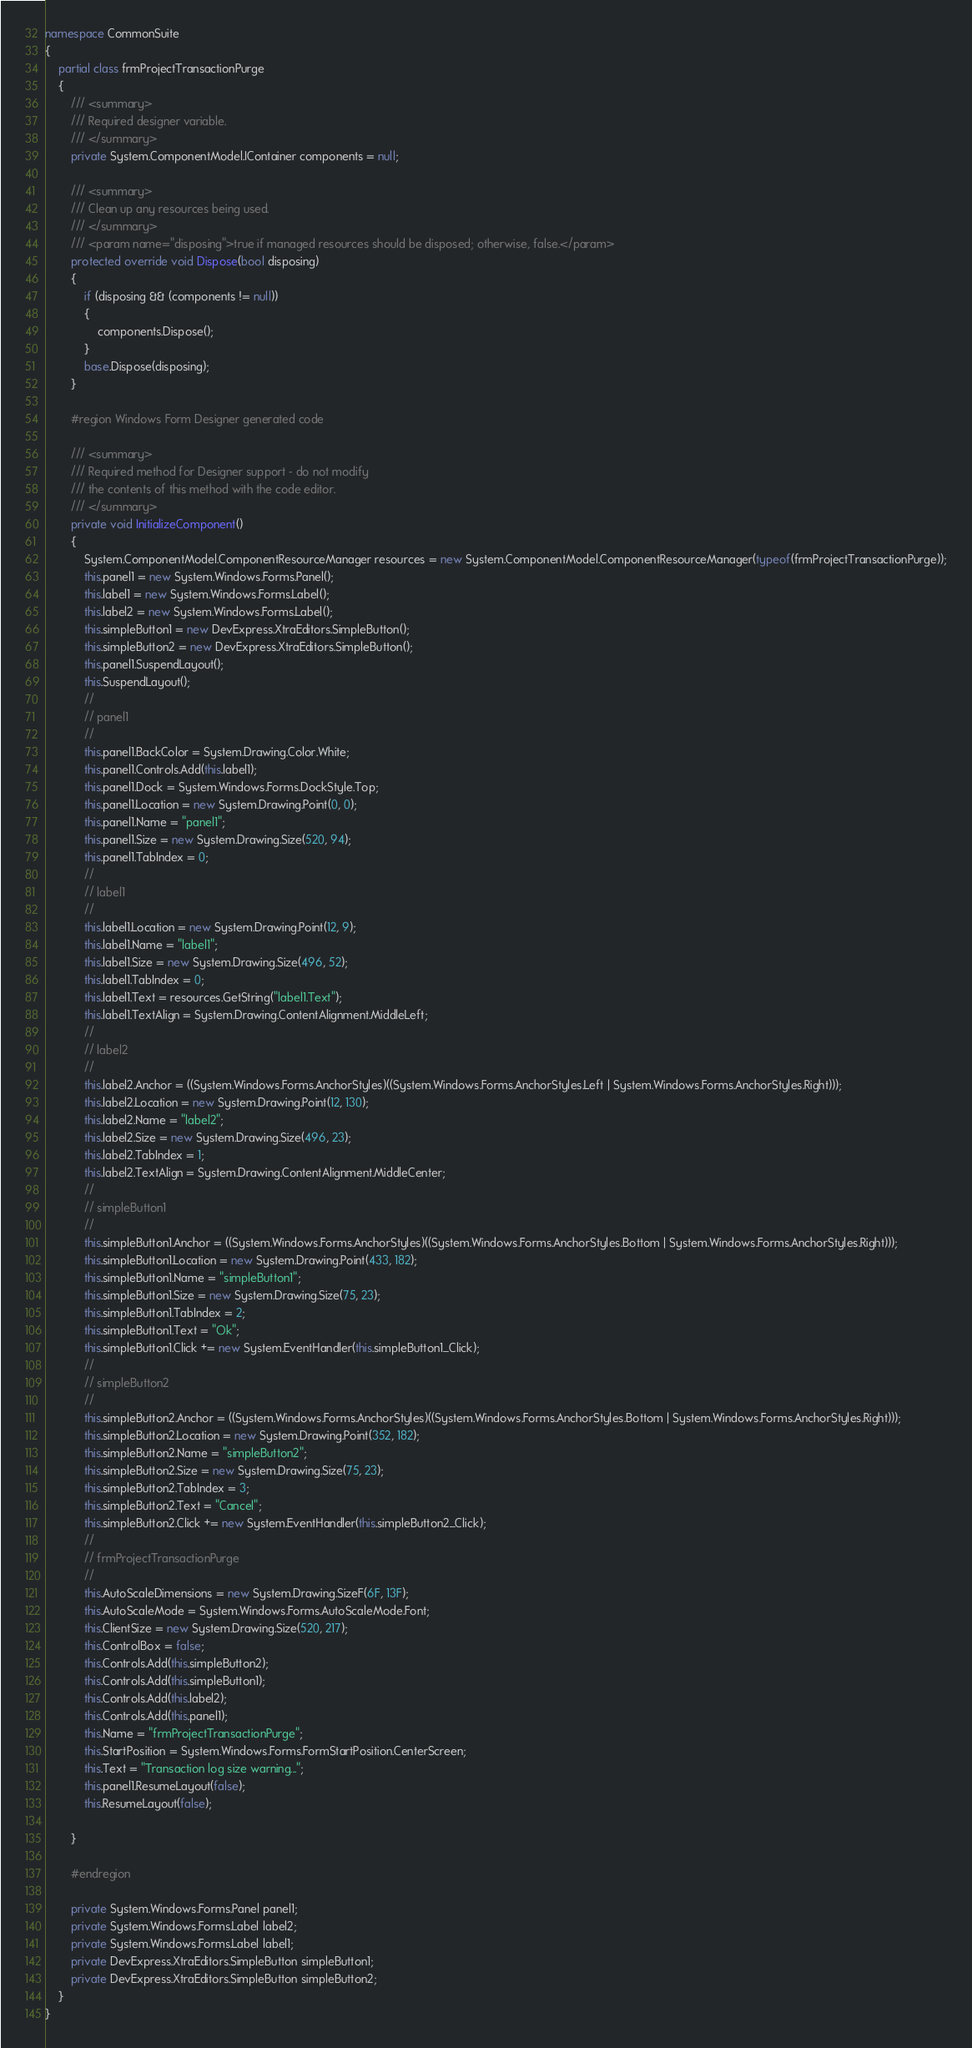<code> <loc_0><loc_0><loc_500><loc_500><_C#_>namespace CommonSuite
{
    partial class frmProjectTransactionPurge
    {
        /// <summary>
        /// Required designer variable.
        /// </summary>
        private System.ComponentModel.IContainer components = null;

        /// <summary>
        /// Clean up any resources being used.
        /// </summary>
        /// <param name="disposing">true if managed resources should be disposed; otherwise, false.</param>
        protected override void Dispose(bool disposing)
        {
            if (disposing && (components != null))
            {
                components.Dispose();
            }
            base.Dispose(disposing);
        }

        #region Windows Form Designer generated code

        /// <summary>
        /// Required method for Designer support - do not modify
        /// the contents of this method with the code editor.
        /// </summary>
        private void InitializeComponent()
        {
            System.ComponentModel.ComponentResourceManager resources = new System.ComponentModel.ComponentResourceManager(typeof(frmProjectTransactionPurge));
            this.panel1 = new System.Windows.Forms.Panel();
            this.label1 = new System.Windows.Forms.Label();
            this.label2 = new System.Windows.Forms.Label();
            this.simpleButton1 = new DevExpress.XtraEditors.SimpleButton();
            this.simpleButton2 = new DevExpress.XtraEditors.SimpleButton();
            this.panel1.SuspendLayout();
            this.SuspendLayout();
            // 
            // panel1
            // 
            this.panel1.BackColor = System.Drawing.Color.White;
            this.panel1.Controls.Add(this.label1);
            this.panel1.Dock = System.Windows.Forms.DockStyle.Top;
            this.panel1.Location = new System.Drawing.Point(0, 0);
            this.panel1.Name = "panel1";
            this.panel1.Size = new System.Drawing.Size(520, 94);
            this.panel1.TabIndex = 0;
            // 
            // label1
            // 
            this.label1.Location = new System.Drawing.Point(12, 9);
            this.label1.Name = "label1";
            this.label1.Size = new System.Drawing.Size(496, 52);
            this.label1.TabIndex = 0;
            this.label1.Text = resources.GetString("label1.Text");
            this.label1.TextAlign = System.Drawing.ContentAlignment.MiddleLeft;
            // 
            // label2
            // 
            this.label2.Anchor = ((System.Windows.Forms.AnchorStyles)((System.Windows.Forms.AnchorStyles.Left | System.Windows.Forms.AnchorStyles.Right)));
            this.label2.Location = new System.Drawing.Point(12, 130);
            this.label2.Name = "label2";
            this.label2.Size = new System.Drawing.Size(496, 23);
            this.label2.TabIndex = 1;
            this.label2.TextAlign = System.Drawing.ContentAlignment.MiddleCenter;
            // 
            // simpleButton1
            // 
            this.simpleButton1.Anchor = ((System.Windows.Forms.AnchorStyles)((System.Windows.Forms.AnchorStyles.Bottom | System.Windows.Forms.AnchorStyles.Right)));
            this.simpleButton1.Location = new System.Drawing.Point(433, 182);
            this.simpleButton1.Name = "simpleButton1";
            this.simpleButton1.Size = new System.Drawing.Size(75, 23);
            this.simpleButton1.TabIndex = 2;
            this.simpleButton1.Text = "Ok";
            this.simpleButton1.Click += new System.EventHandler(this.simpleButton1_Click);
            // 
            // simpleButton2
            // 
            this.simpleButton2.Anchor = ((System.Windows.Forms.AnchorStyles)((System.Windows.Forms.AnchorStyles.Bottom | System.Windows.Forms.AnchorStyles.Right)));
            this.simpleButton2.Location = new System.Drawing.Point(352, 182);
            this.simpleButton2.Name = "simpleButton2";
            this.simpleButton2.Size = new System.Drawing.Size(75, 23);
            this.simpleButton2.TabIndex = 3;
            this.simpleButton2.Text = "Cancel";
            this.simpleButton2.Click += new System.EventHandler(this.simpleButton2_Click);
            // 
            // frmProjectTransactionPurge
            // 
            this.AutoScaleDimensions = new System.Drawing.SizeF(6F, 13F);
            this.AutoScaleMode = System.Windows.Forms.AutoScaleMode.Font;
            this.ClientSize = new System.Drawing.Size(520, 217);
            this.ControlBox = false;
            this.Controls.Add(this.simpleButton2);
            this.Controls.Add(this.simpleButton1);
            this.Controls.Add(this.label2);
            this.Controls.Add(this.panel1);
            this.Name = "frmProjectTransactionPurge";
            this.StartPosition = System.Windows.Forms.FormStartPosition.CenterScreen;
            this.Text = "Transaction log size warning...";
            this.panel1.ResumeLayout(false);
            this.ResumeLayout(false);

        }

        #endregion

        private System.Windows.Forms.Panel panel1;
        private System.Windows.Forms.Label label2;
        private System.Windows.Forms.Label label1;
        private DevExpress.XtraEditors.SimpleButton simpleButton1;
        private DevExpress.XtraEditors.SimpleButton simpleButton2;
    }
}</code> 